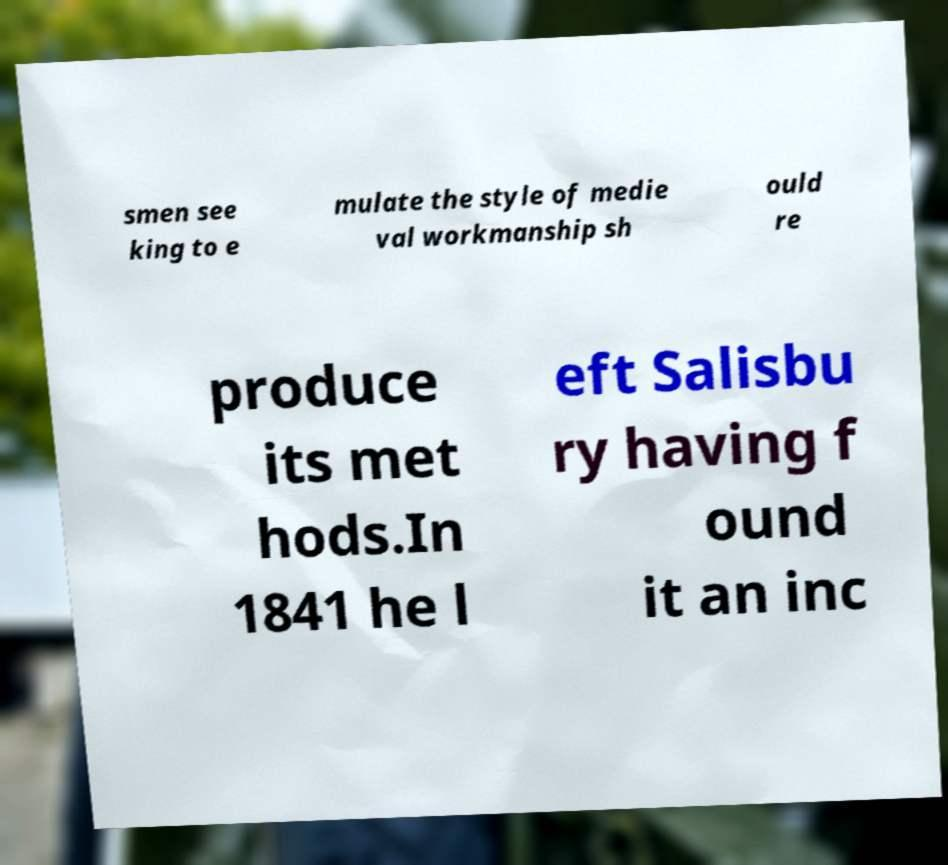What messages or text are displayed in this image? I need them in a readable, typed format. smen see king to e mulate the style of medie val workmanship sh ould re produce its met hods.In 1841 he l eft Salisbu ry having f ound it an inc 